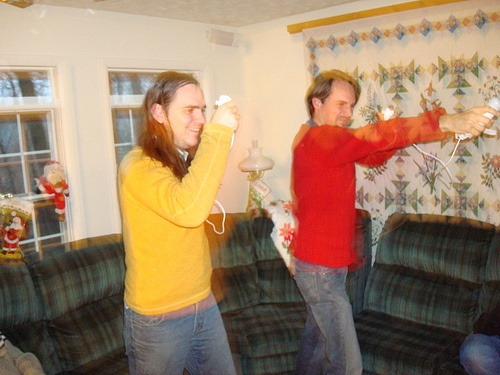Describe the objects in this image and their specific colors. I can see couch in tan, black, gray, and maroon tones, people in tan, gold, gray, and orange tones, people in tan, red, and gray tones, remote in tan and lightgray tones, and remote in tan and white tones in this image. 